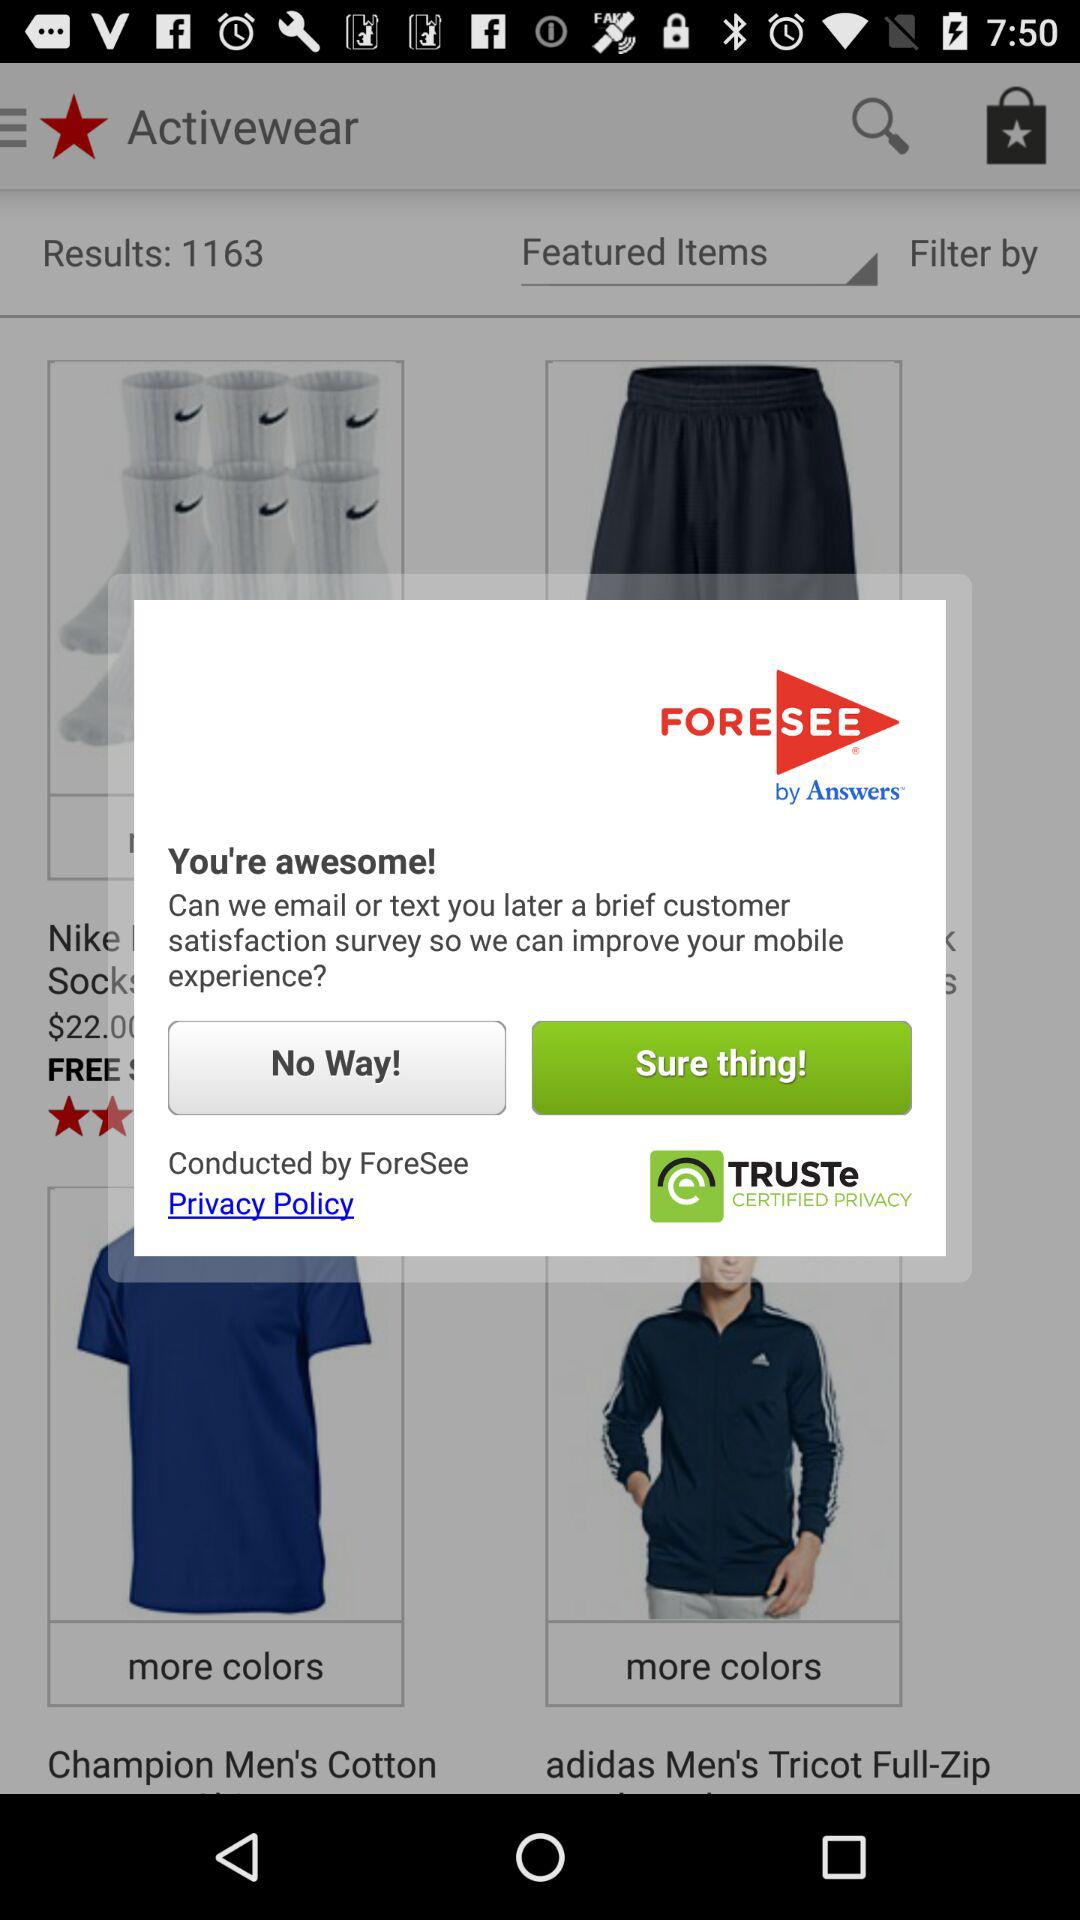By whom was the survey conducted? The survey was conducted by "ForeSee". 